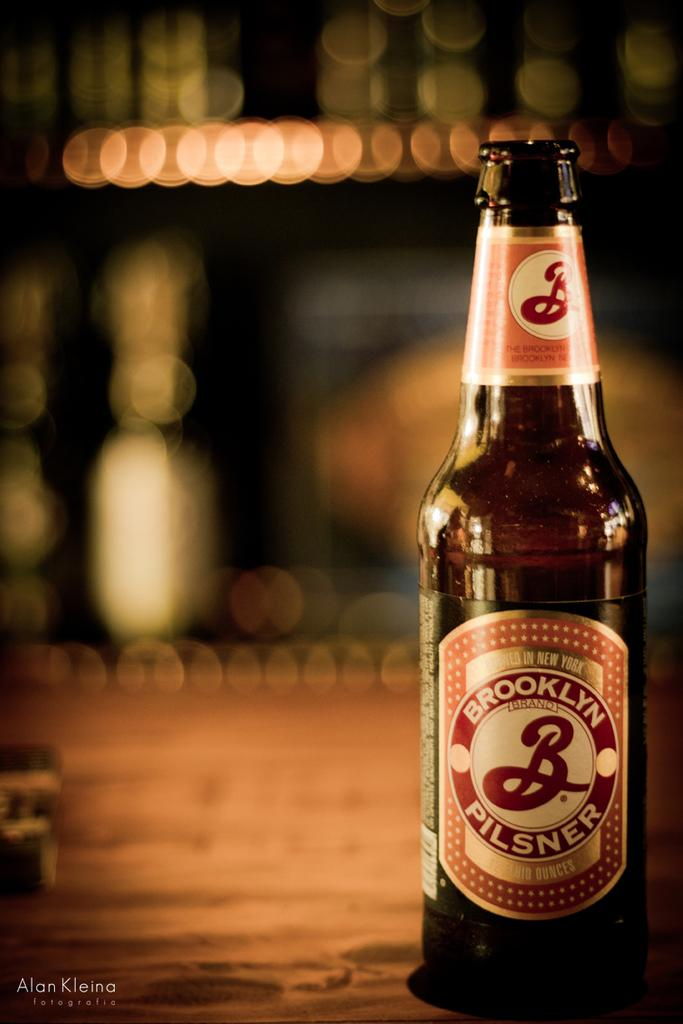What is the main object in the image? There is a wine bottle in the image. Can you describe the background of the image? The background of the image is blurred. How much power does the wine bottle generate in the image? The wine bottle does not generate power in the image; it is an inanimate object. 